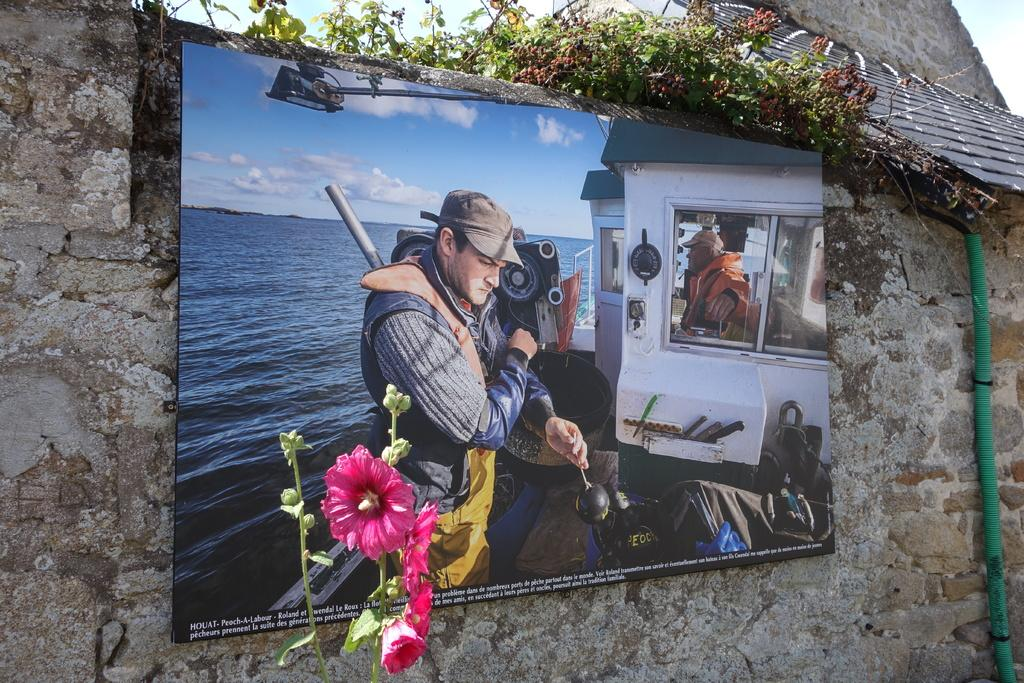What is on the wall in the image? A board is attached to the wall. What is depicted on the board? Photos of people on a boat are present on the board. Where is the boat located in the images? The boat is on water. What can be seen in the background of the image? The sky is visible in the background of the image. How many geese are swimming alongside the boat in the image? There are no geese present in the image; it only features photos of people on a boat. What type of border is depicted in the image? There is no border depicted in the image; it only shows a wall with a board displaying photos of people on a boat. 